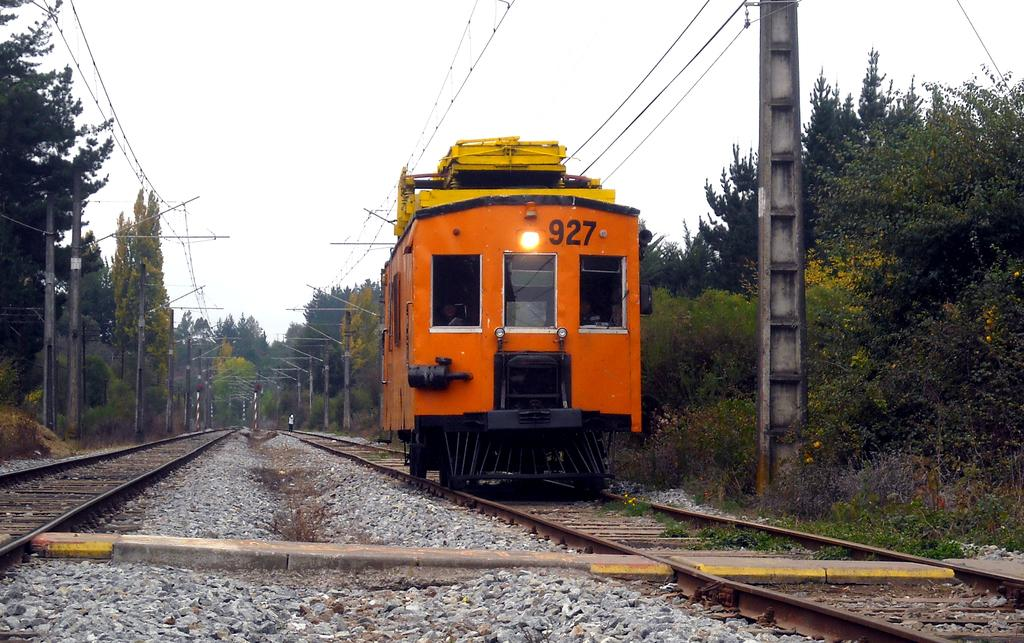What is the main subject of the image? The main subject of the image is a train compartment. Where is the train compartment located? The train compartment is on a railway track. What can be seen around the railway track? There are many trees and poles around the railway track. What are the poles used for? The poles have wires attached to them. Can you tell me how many partners are visible in the image? There are no partners present in the image; it features a train compartment on a railway track surrounded by trees and poles. 